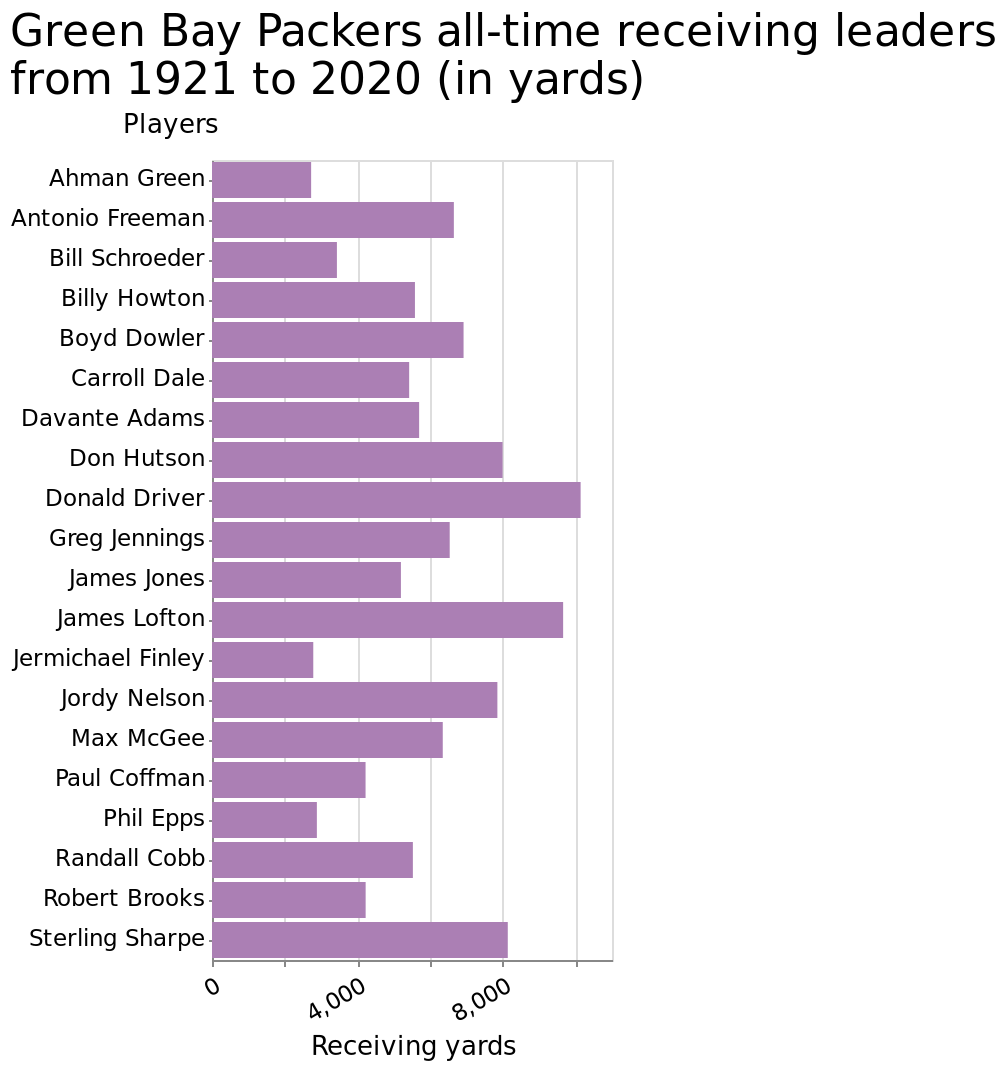<image>
What is the range of the x-axis in the bar plot? The x-axis in the bar plot ranges from 0 to 10,000 in terms of receiving yards. 